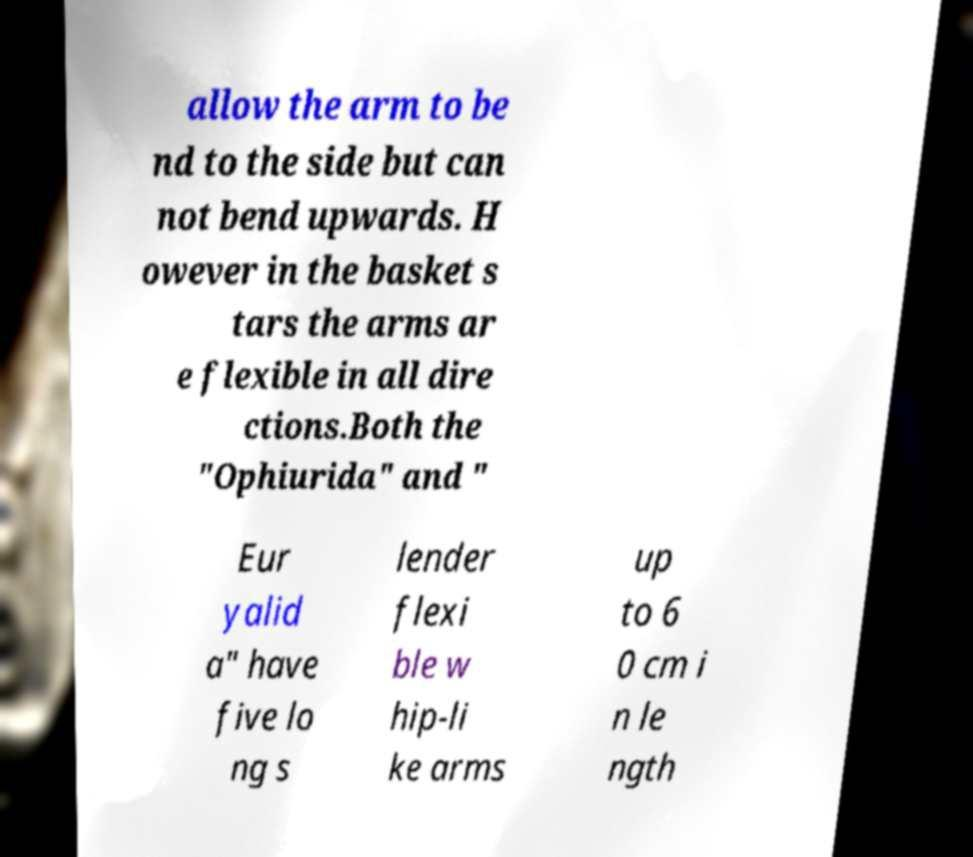Can you accurately transcribe the text from the provided image for me? allow the arm to be nd to the side but can not bend upwards. H owever in the basket s tars the arms ar e flexible in all dire ctions.Both the "Ophiurida" and " Eur yalid a" have five lo ng s lender flexi ble w hip-li ke arms up to 6 0 cm i n le ngth 